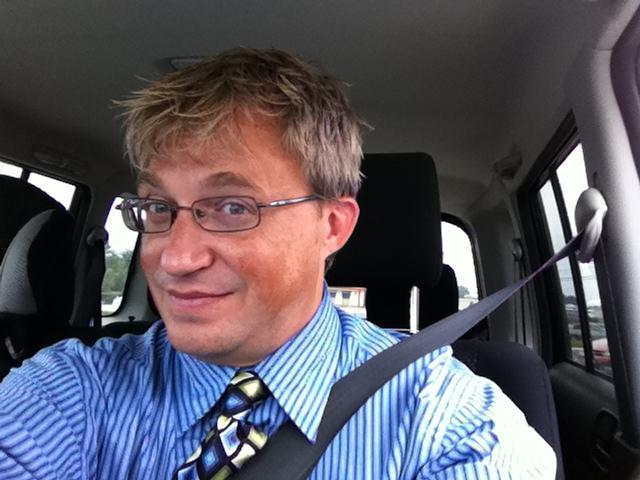How many giraffes are in this picture?
Give a very brief answer. 0. 